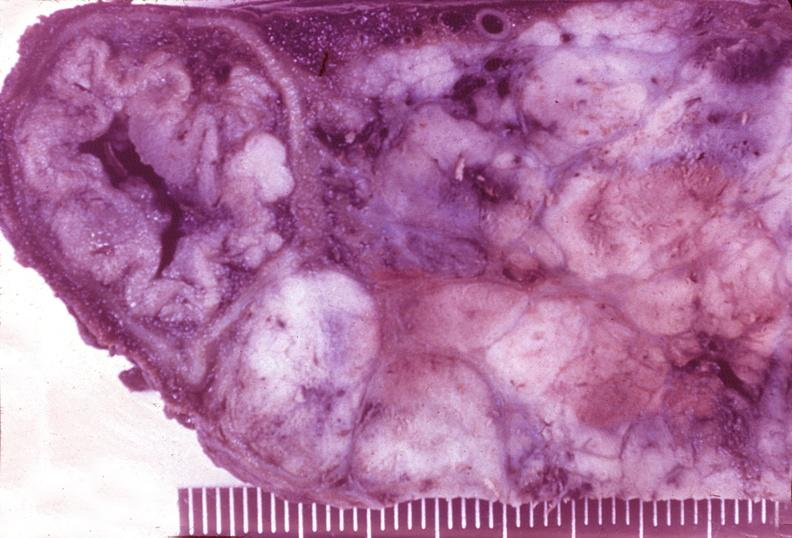s excellent multiple lesions present?
Answer the question using a single word or phrase. No 